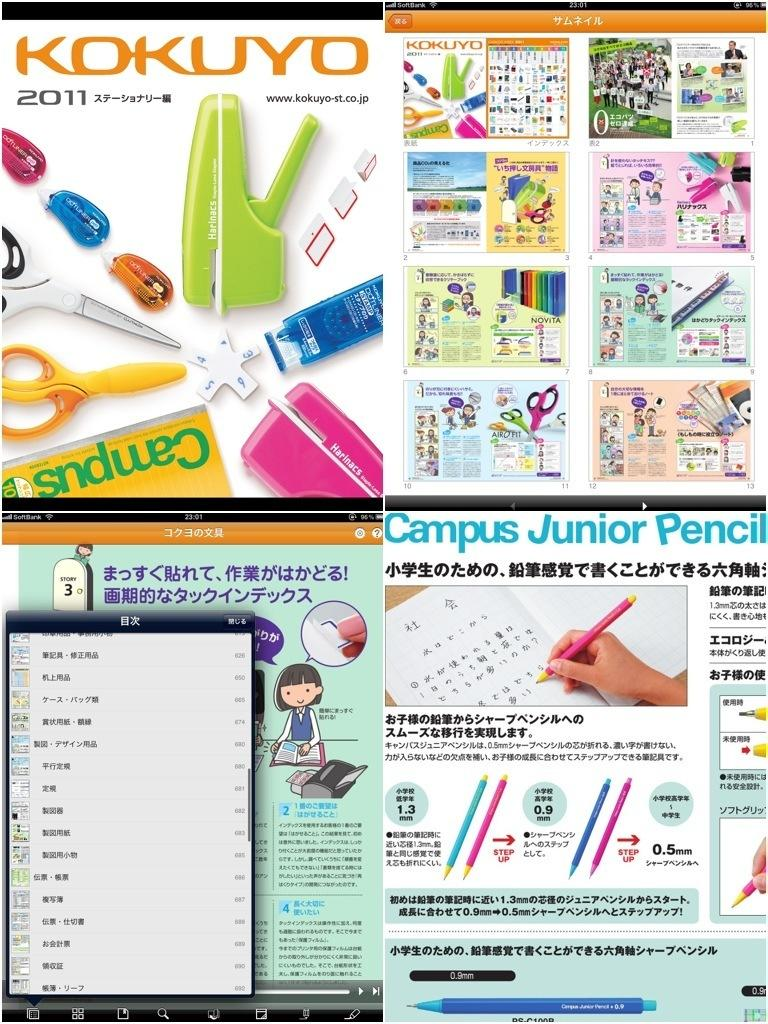<image>
Describe the image concisely. Collage of photos with one saying Kokuyo with staplers on it. 